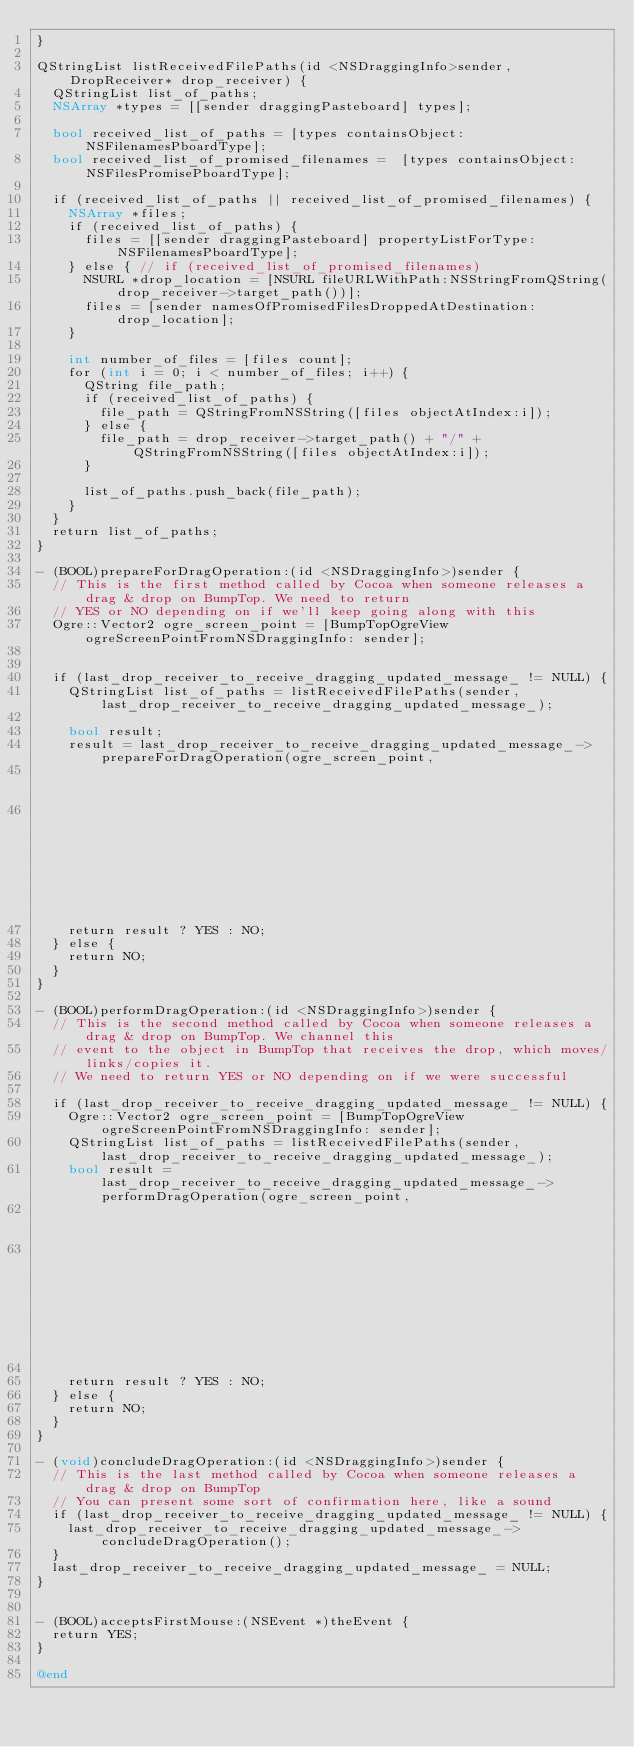Convert code to text. <code><loc_0><loc_0><loc_500><loc_500><_ObjectiveC_>}

QStringList listReceivedFilePaths(id <NSDraggingInfo>sender, DropReceiver* drop_receiver) {
  QStringList list_of_paths;
  NSArray *types = [[sender draggingPasteboard] types];

  bool received_list_of_paths = [types containsObject:NSFilenamesPboardType];
  bool received_list_of_promised_filenames =  [types containsObject:NSFilesPromisePboardType];

  if (received_list_of_paths || received_list_of_promised_filenames) {
    NSArray *files;
    if (received_list_of_paths) {
      files = [[sender draggingPasteboard] propertyListForType:NSFilenamesPboardType];
    } else { // if (received_list_of_promised_filenames)
      NSURL *drop_location = [NSURL fileURLWithPath:NSStringFromQString(drop_receiver->target_path())];
      files = [sender namesOfPromisedFilesDroppedAtDestination:drop_location];
    }

    int number_of_files = [files count];
    for (int i = 0; i < number_of_files; i++) {
      QString file_path;
      if (received_list_of_paths) {
        file_path = QStringFromNSString([files objectAtIndex:i]);
      } else {
        file_path = drop_receiver->target_path() + "/" + QStringFromNSString([files objectAtIndex:i]);
      }

      list_of_paths.push_back(file_path);
    }
  }
  return list_of_paths;
}

- (BOOL)prepareForDragOperation:(id <NSDraggingInfo>)sender {
  // This is the first method called by Cocoa when someone releases a drag & drop on BumpTop. We need to return
  // YES or NO depending on if we'll keep going along with this
  Ogre::Vector2 ogre_screen_point = [BumpTopOgreView ogreScreenPointFromNSDraggingInfo: sender];


  if (last_drop_receiver_to_receive_dragging_updated_message_ != NULL) {
    QStringList list_of_paths = listReceivedFilePaths(sender, last_drop_receiver_to_receive_dragging_updated_message_);

    bool result;
    result = last_drop_receiver_to_receive_dragging_updated_message_->prepareForDragOperation(ogre_screen_point,
                                                                                              list_of_paths,
                                                                                              last_drag_operation_returned_by_drop_receiver_);  // NOLINT
    return result ? YES : NO;
  } else {
    return NO;
  }
}

- (BOOL)performDragOperation:(id <NSDraggingInfo>)sender {
  // This is the second method called by Cocoa when someone releases a drag & drop on BumpTop. We channel this
  // event to the object in BumpTop that receives the drop, which moves/links/copies it.
  // We need to return YES or NO depending on if we were successful

  if (last_drop_receiver_to_receive_dragging_updated_message_ != NULL) {
    Ogre::Vector2 ogre_screen_point = [BumpTopOgreView ogreScreenPointFromNSDraggingInfo: sender];
    QStringList list_of_paths = listReceivedFilePaths(sender, last_drop_receiver_to_receive_dragging_updated_message_);
    bool result = last_drop_receiver_to_receive_dragging_updated_message_->performDragOperation(ogre_screen_point,
                                                                                                list_of_paths,
                                                                                                last_drag_operation_returned_by_drop_receiver_);  // NOLINT

    return result ? YES : NO;
  } else {
    return NO;
  }
}

- (void)concludeDragOperation:(id <NSDraggingInfo>)sender {
  // This is the last method called by Cocoa when someone releases a drag & drop on BumpTop
  // You can present some sort of confirmation here, like a sound
  if (last_drop_receiver_to_receive_dragging_updated_message_ != NULL) {
    last_drop_receiver_to_receive_dragging_updated_message_->concludeDragOperation();
  }
  last_drop_receiver_to_receive_dragging_updated_message_ = NULL;
}


- (BOOL)acceptsFirstMouse:(NSEvent *)theEvent {
  return YES;
}

@end
</code> 